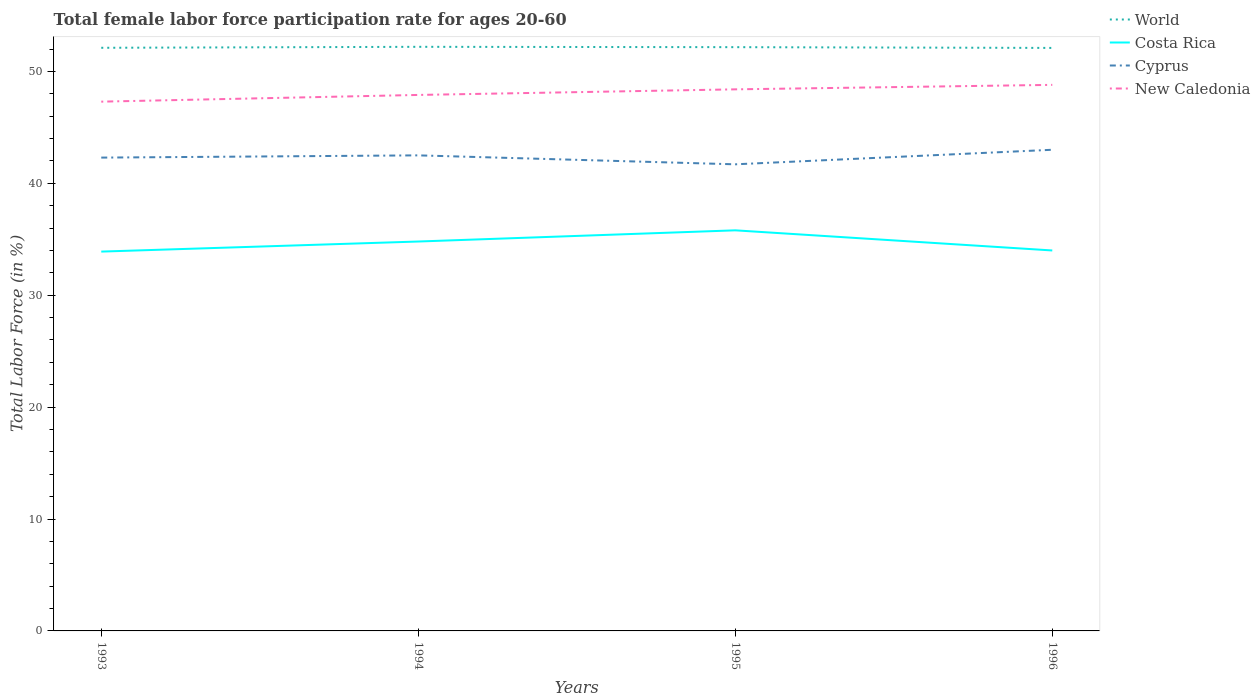How many different coloured lines are there?
Keep it short and to the point. 4. Does the line corresponding to Costa Rica intersect with the line corresponding to Cyprus?
Your answer should be compact. No. Is the number of lines equal to the number of legend labels?
Your answer should be compact. Yes. Across all years, what is the maximum female labor force participation rate in New Caledonia?
Give a very brief answer. 47.3. What is the total female labor force participation rate in New Caledonia in the graph?
Make the answer very short. -0.9. What is the difference between the highest and the second highest female labor force participation rate in Cyprus?
Ensure brevity in your answer.  1.3. What is the difference between the highest and the lowest female labor force participation rate in World?
Your response must be concise. 2. How many lines are there?
Keep it short and to the point. 4. What is the difference between two consecutive major ticks on the Y-axis?
Your answer should be very brief. 10. Are the values on the major ticks of Y-axis written in scientific E-notation?
Make the answer very short. No. Does the graph contain any zero values?
Give a very brief answer. No. How many legend labels are there?
Your response must be concise. 4. How are the legend labels stacked?
Your response must be concise. Vertical. What is the title of the graph?
Give a very brief answer. Total female labor force participation rate for ages 20-60. Does "Latvia" appear as one of the legend labels in the graph?
Make the answer very short. No. What is the label or title of the X-axis?
Your answer should be very brief. Years. What is the label or title of the Y-axis?
Keep it short and to the point. Total Labor Force (in %). What is the Total Labor Force (in %) in World in 1993?
Your answer should be compact. 52.11. What is the Total Labor Force (in %) of Costa Rica in 1993?
Your answer should be compact. 33.9. What is the Total Labor Force (in %) in Cyprus in 1993?
Make the answer very short. 42.3. What is the Total Labor Force (in %) in New Caledonia in 1993?
Your answer should be compact. 47.3. What is the Total Labor Force (in %) of World in 1994?
Provide a short and direct response. 52.2. What is the Total Labor Force (in %) of Costa Rica in 1994?
Your answer should be compact. 34.8. What is the Total Labor Force (in %) of Cyprus in 1994?
Offer a very short reply. 42.5. What is the Total Labor Force (in %) in New Caledonia in 1994?
Offer a terse response. 47.9. What is the Total Labor Force (in %) in World in 1995?
Offer a terse response. 52.17. What is the Total Labor Force (in %) in Costa Rica in 1995?
Provide a short and direct response. 35.8. What is the Total Labor Force (in %) of Cyprus in 1995?
Make the answer very short. 41.7. What is the Total Labor Force (in %) of New Caledonia in 1995?
Your answer should be compact. 48.4. What is the Total Labor Force (in %) of World in 1996?
Your answer should be compact. 52.1. What is the Total Labor Force (in %) in Costa Rica in 1996?
Your answer should be very brief. 34. What is the Total Labor Force (in %) in Cyprus in 1996?
Give a very brief answer. 43. What is the Total Labor Force (in %) of New Caledonia in 1996?
Provide a succinct answer. 48.8. Across all years, what is the maximum Total Labor Force (in %) in World?
Your answer should be compact. 52.2. Across all years, what is the maximum Total Labor Force (in %) in Costa Rica?
Your answer should be compact. 35.8. Across all years, what is the maximum Total Labor Force (in %) of New Caledonia?
Keep it short and to the point. 48.8. Across all years, what is the minimum Total Labor Force (in %) in World?
Offer a terse response. 52.1. Across all years, what is the minimum Total Labor Force (in %) in Costa Rica?
Give a very brief answer. 33.9. Across all years, what is the minimum Total Labor Force (in %) of Cyprus?
Provide a succinct answer. 41.7. Across all years, what is the minimum Total Labor Force (in %) of New Caledonia?
Offer a terse response. 47.3. What is the total Total Labor Force (in %) in World in the graph?
Offer a very short reply. 208.59. What is the total Total Labor Force (in %) in Costa Rica in the graph?
Offer a terse response. 138.5. What is the total Total Labor Force (in %) of Cyprus in the graph?
Give a very brief answer. 169.5. What is the total Total Labor Force (in %) of New Caledonia in the graph?
Provide a short and direct response. 192.4. What is the difference between the Total Labor Force (in %) in World in 1993 and that in 1994?
Offer a terse response. -0.09. What is the difference between the Total Labor Force (in %) in Costa Rica in 1993 and that in 1994?
Keep it short and to the point. -0.9. What is the difference between the Total Labor Force (in %) in Cyprus in 1993 and that in 1994?
Give a very brief answer. -0.2. What is the difference between the Total Labor Force (in %) in World in 1993 and that in 1995?
Your answer should be compact. -0.06. What is the difference between the Total Labor Force (in %) of Costa Rica in 1993 and that in 1995?
Ensure brevity in your answer.  -1.9. What is the difference between the Total Labor Force (in %) in Cyprus in 1993 and that in 1995?
Offer a very short reply. 0.6. What is the difference between the Total Labor Force (in %) in New Caledonia in 1993 and that in 1995?
Your response must be concise. -1.1. What is the difference between the Total Labor Force (in %) in World in 1993 and that in 1996?
Keep it short and to the point. 0.01. What is the difference between the Total Labor Force (in %) of World in 1994 and that in 1995?
Your answer should be compact. 0.03. What is the difference between the Total Labor Force (in %) of Cyprus in 1994 and that in 1995?
Provide a short and direct response. 0.8. What is the difference between the Total Labor Force (in %) of New Caledonia in 1994 and that in 1995?
Make the answer very short. -0.5. What is the difference between the Total Labor Force (in %) in World in 1994 and that in 1996?
Keep it short and to the point. 0.1. What is the difference between the Total Labor Force (in %) in Costa Rica in 1994 and that in 1996?
Provide a short and direct response. 0.8. What is the difference between the Total Labor Force (in %) of Cyprus in 1994 and that in 1996?
Make the answer very short. -0.5. What is the difference between the Total Labor Force (in %) in New Caledonia in 1994 and that in 1996?
Keep it short and to the point. -0.9. What is the difference between the Total Labor Force (in %) in World in 1995 and that in 1996?
Make the answer very short. 0.07. What is the difference between the Total Labor Force (in %) in New Caledonia in 1995 and that in 1996?
Provide a short and direct response. -0.4. What is the difference between the Total Labor Force (in %) of World in 1993 and the Total Labor Force (in %) of Costa Rica in 1994?
Keep it short and to the point. 17.31. What is the difference between the Total Labor Force (in %) in World in 1993 and the Total Labor Force (in %) in Cyprus in 1994?
Provide a succinct answer. 9.61. What is the difference between the Total Labor Force (in %) in World in 1993 and the Total Labor Force (in %) in New Caledonia in 1994?
Give a very brief answer. 4.21. What is the difference between the Total Labor Force (in %) in Costa Rica in 1993 and the Total Labor Force (in %) in Cyprus in 1994?
Provide a succinct answer. -8.6. What is the difference between the Total Labor Force (in %) of World in 1993 and the Total Labor Force (in %) of Costa Rica in 1995?
Offer a very short reply. 16.31. What is the difference between the Total Labor Force (in %) in World in 1993 and the Total Labor Force (in %) in Cyprus in 1995?
Give a very brief answer. 10.41. What is the difference between the Total Labor Force (in %) of World in 1993 and the Total Labor Force (in %) of New Caledonia in 1995?
Provide a short and direct response. 3.71. What is the difference between the Total Labor Force (in %) in Costa Rica in 1993 and the Total Labor Force (in %) in Cyprus in 1995?
Your answer should be compact. -7.8. What is the difference between the Total Labor Force (in %) of Cyprus in 1993 and the Total Labor Force (in %) of New Caledonia in 1995?
Provide a succinct answer. -6.1. What is the difference between the Total Labor Force (in %) in World in 1993 and the Total Labor Force (in %) in Costa Rica in 1996?
Provide a succinct answer. 18.11. What is the difference between the Total Labor Force (in %) in World in 1993 and the Total Labor Force (in %) in Cyprus in 1996?
Provide a succinct answer. 9.11. What is the difference between the Total Labor Force (in %) in World in 1993 and the Total Labor Force (in %) in New Caledonia in 1996?
Your answer should be very brief. 3.31. What is the difference between the Total Labor Force (in %) of Costa Rica in 1993 and the Total Labor Force (in %) of New Caledonia in 1996?
Your answer should be compact. -14.9. What is the difference between the Total Labor Force (in %) in World in 1994 and the Total Labor Force (in %) in Costa Rica in 1995?
Your response must be concise. 16.4. What is the difference between the Total Labor Force (in %) in World in 1994 and the Total Labor Force (in %) in Cyprus in 1995?
Make the answer very short. 10.5. What is the difference between the Total Labor Force (in %) of World in 1994 and the Total Labor Force (in %) of New Caledonia in 1995?
Make the answer very short. 3.8. What is the difference between the Total Labor Force (in %) of Costa Rica in 1994 and the Total Labor Force (in %) of New Caledonia in 1995?
Offer a terse response. -13.6. What is the difference between the Total Labor Force (in %) in Cyprus in 1994 and the Total Labor Force (in %) in New Caledonia in 1995?
Ensure brevity in your answer.  -5.9. What is the difference between the Total Labor Force (in %) of World in 1994 and the Total Labor Force (in %) of Costa Rica in 1996?
Make the answer very short. 18.2. What is the difference between the Total Labor Force (in %) in World in 1994 and the Total Labor Force (in %) in Cyprus in 1996?
Keep it short and to the point. 9.2. What is the difference between the Total Labor Force (in %) in World in 1994 and the Total Labor Force (in %) in New Caledonia in 1996?
Your answer should be very brief. 3.4. What is the difference between the Total Labor Force (in %) in Costa Rica in 1994 and the Total Labor Force (in %) in Cyprus in 1996?
Ensure brevity in your answer.  -8.2. What is the difference between the Total Labor Force (in %) in Costa Rica in 1994 and the Total Labor Force (in %) in New Caledonia in 1996?
Your answer should be compact. -14. What is the difference between the Total Labor Force (in %) of Cyprus in 1994 and the Total Labor Force (in %) of New Caledonia in 1996?
Your answer should be very brief. -6.3. What is the difference between the Total Labor Force (in %) of World in 1995 and the Total Labor Force (in %) of Costa Rica in 1996?
Provide a short and direct response. 18.17. What is the difference between the Total Labor Force (in %) in World in 1995 and the Total Labor Force (in %) in Cyprus in 1996?
Your answer should be very brief. 9.17. What is the difference between the Total Labor Force (in %) in World in 1995 and the Total Labor Force (in %) in New Caledonia in 1996?
Offer a terse response. 3.37. What is the average Total Labor Force (in %) in World per year?
Your answer should be compact. 52.15. What is the average Total Labor Force (in %) in Costa Rica per year?
Your answer should be very brief. 34.62. What is the average Total Labor Force (in %) of Cyprus per year?
Provide a short and direct response. 42.38. What is the average Total Labor Force (in %) of New Caledonia per year?
Your answer should be very brief. 48.1. In the year 1993, what is the difference between the Total Labor Force (in %) of World and Total Labor Force (in %) of Costa Rica?
Give a very brief answer. 18.21. In the year 1993, what is the difference between the Total Labor Force (in %) of World and Total Labor Force (in %) of Cyprus?
Offer a terse response. 9.81. In the year 1993, what is the difference between the Total Labor Force (in %) in World and Total Labor Force (in %) in New Caledonia?
Provide a short and direct response. 4.81. In the year 1993, what is the difference between the Total Labor Force (in %) of Costa Rica and Total Labor Force (in %) of Cyprus?
Your answer should be compact. -8.4. In the year 1993, what is the difference between the Total Labor Force (in %) of Cyprus and Total Labor Force (in %) of New Caledonia?
Keep it short and to the point. -5. In the year 1994, what is the difference between the Total Labor Force (in %) of World and Total Labor Force (in %) of Costa Rica?
Provide a short and direct response. 17.4. In the year 1994, what is the difference between the Total Labor Force (in %) of World and Total Labor Force (in %) of Cyprus?
Provide a short and direct response. 9.7. In the year 1994, what is the difference between the Total Labor Force (in %) of World and Total Labor Force (in %) of New Caledonia?
Your answer should be compact. 4.3. In the year 1994, what is the difference between the Total Labor Force (in %) in Costa Rica and Total Labor Force (in %) in Cyprus?
Your answer should be very brief. -7.7. In the year 1994, what is the difference between the Total Labor Force (in %) in Cyprus and Total Labor Force (in %) in New Caledonia?
Keep it short and to the point. -5.4. In the year 1995, what is the difference between the Total Labor Force (in %) of World and Total Labor Force (in %) of Costa Rica?
Keep it short and to the point. 16.37. In the year 1995, what is the difference between the Total Labor Force (in %) in World and Total Labor Force (in %) in Cyprus?
Offer a terse response. 10.47. In the year 1995, what is the difference between the Total Labor Force (in %) in World and Total Labor Force (in %) in New Caledonia?
Your answer should be very brief. 3.77. In the year 1995, what is the difference between the Total Labor Force (in %) in Costa Rica and Total Labor Force (in %) in Cyprus?
Your answer should be very brief. -5.9. In the year 1995, what is the difference between the Total Labor Force (in %) in Costa Rica and Total Labor Force (in %) in New Caledonia?
Offer a very short reply. -12.6. In the year 1996, what is the difference between the Total Labor Force (in %) of World and Total Labor Force (in %) of Costa Rica?
Give a very brief answer. 18.1. In the year 1996, what is the difference between the Total Labor Force (in %) in World and Total Labor Force (in %) in Cyprus?
Offer a very short reply. 9.1. In the year 1996, what is the difference between the Total Labor Force (in %) in World and Total Labor Force (in %) in New Caledonia?
Keep it short and to the point. 3.3. In the year 1996, what is the difference between the Total Labor Force (in %) of Costa Rica and Total Labor Force (in %) of New Caledonia?
Offer a very short reply. -14.8. What is the ratio of the Total Labor Force (in %) of World in 1993 to that in 1994?
Provide a succinct answer. 1. What is the ratio of the Total Labor Force (in %) in Costa Rica in 1993 to that in 1994?
Make the answer very short. 0.97. What is the ratio of the Total Labor Force (in %) of Cyprus in 1993 to that in 1994?
Offer a terse response. 1. What is the ratio of the Total Labor Force (in %) in New Caledonia in 1993 to that in 1994?
Your answer should be compact. 0.99. What is the ratio of the Total Labor Force (in %) of World in 1993 to that in 1995?
Your answer should be compact. 1. What is the ratio of the Total Labor Force (in %) of Costa Rica in 1993 to that in 1995?
Ensure brevity in your answer.  0.95. What is the ratio of the Total Labor Force (in %) in Cyprus in 1993 to that in 1995?
Offer a very short reply. 1.01. What is the ratio of the Total Labor Force (in %) in New Caledonia in 1993 to that in 1995?
Ensure brevity in your answer.  0.98. What is the ratio of the Total Labor Force (in %) in Costa Rica in 1993 to that in 1996?
Your answer should be compact. 1. What is the ratio of the Total Labor Force (in %) of Cyprus in 1993 to that in 1996?
Your response must be concise. 0.98. What is the ratio of the Total Labor Force (in %) of New Caledonia in 1993 to that in 1996?
Your answer should be very brief. 0.97. What is the ratio of the Total Labor Force (in %) in World in 1994 to that in 1995?
Your answer should be very brief. 1. What is the ratio of the Total Labor Force (in %) of Costa Rica in 1994 to that in 1995?
Your answer should be very brief. 0.97. What is the ratio of the Total Labor Force (in %) in Cyprus in 1994 to that in 1995?
Your answer should be very brief. 1.02. What is the ratio of the Total Labor Force (in %) of World in 1994 to that in 1996?
Your answer should be very brief. 1. What is the ratio of the Total Labor Force (in %) of Costa Rica in 1994 to that in 1996?
Keep it short and to the point. 1.02. What is the ratio of the Total Labor Force (in %) in Cyprus in 1994 to that in 1996?
Give a very brief answer. 0.99. What is the ratio of the Total Labor Force (in %) in New Caledonia in 1994 to that in 1996?
Keep it short and to the point. 0.98. What is the ratio of the Total Labor Force (in %) in Costa Rica in 1995 to that in 1996?
Offer a terse response. 1.05. What is the ratio of the Total Labor Force (in %) of Cyprus in 1995 to that in 1996?
Provide a succinct answer. 0.97. What is the difference between the highest and the second highest Total Labor Force (in %) of World?
Give a very brief answer. 0.03. What is the difference between the highest and the second highest Total Labor Force (in %) of Cyprus?
Give a very brief answer. 0.5. What is the difference between the highest and the lowest Total Labor Force (in %) in World?
Provide a short and direct response. 0.1. What is the difference between the highest and the lowest Total Labor Force (in %) of Cyprus?
Provide a short and direct response. 1.3. 